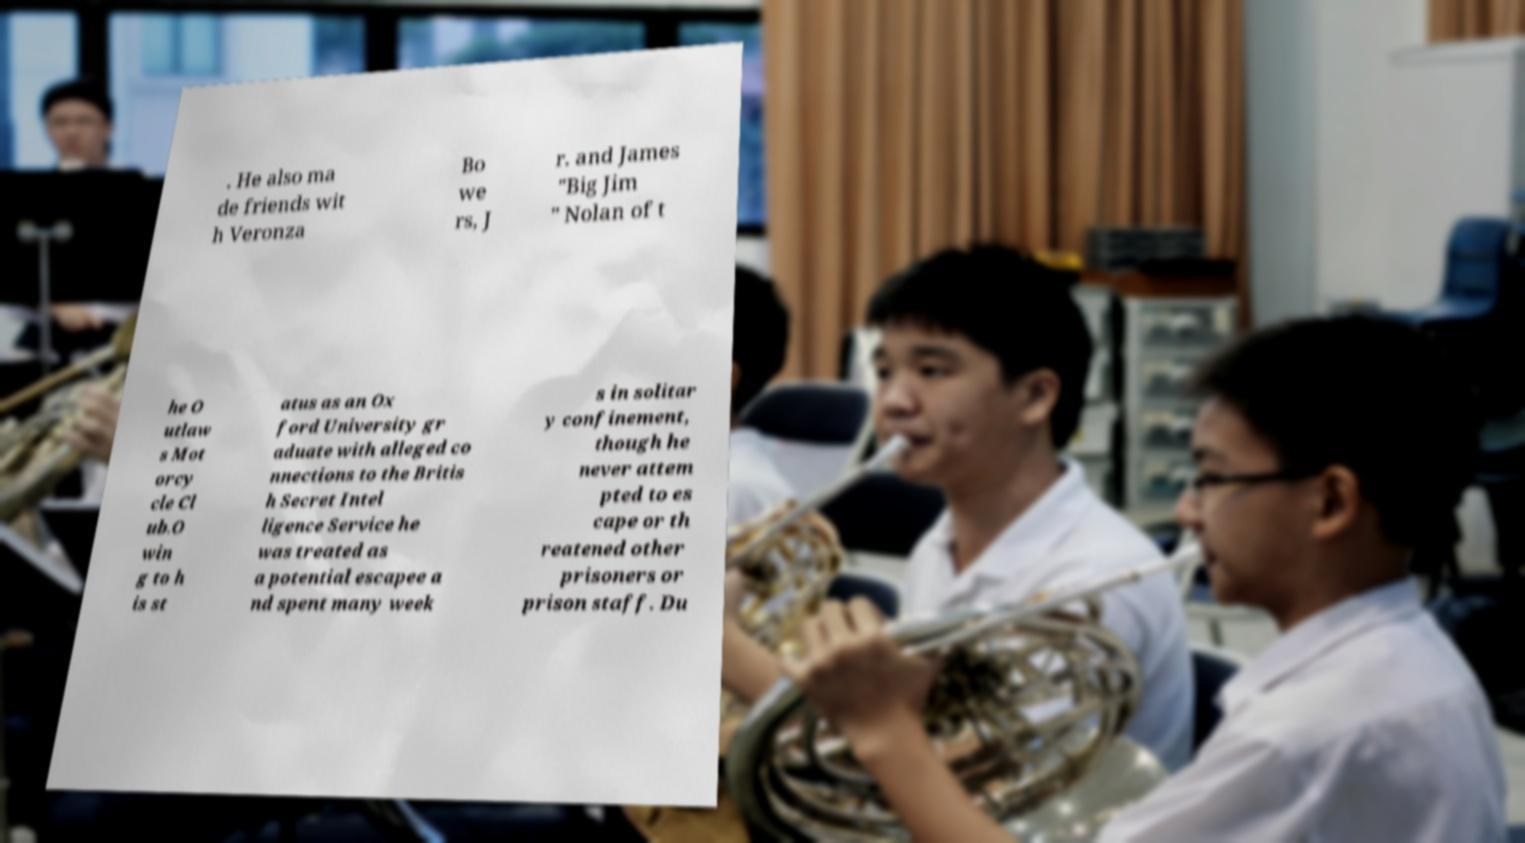There's text embedded in this image that I need extracted. Can you transcribe it verbatim? . He also ma de friends wit h Veronza Bo we rs, J r. and James "Big Jim " Nolan of t he O utlaw s Mot orcy cle Cl ub.O win g to h is st atus as an Ox ford University gr aduate with alleged co nnections to the Britis h Secret Intel ligence Service he was treated as a potential escapee a nd spent many week s in solitar y confinement, though he never attem pted to es cape or th reatened other prisoners or prison staff. Du 